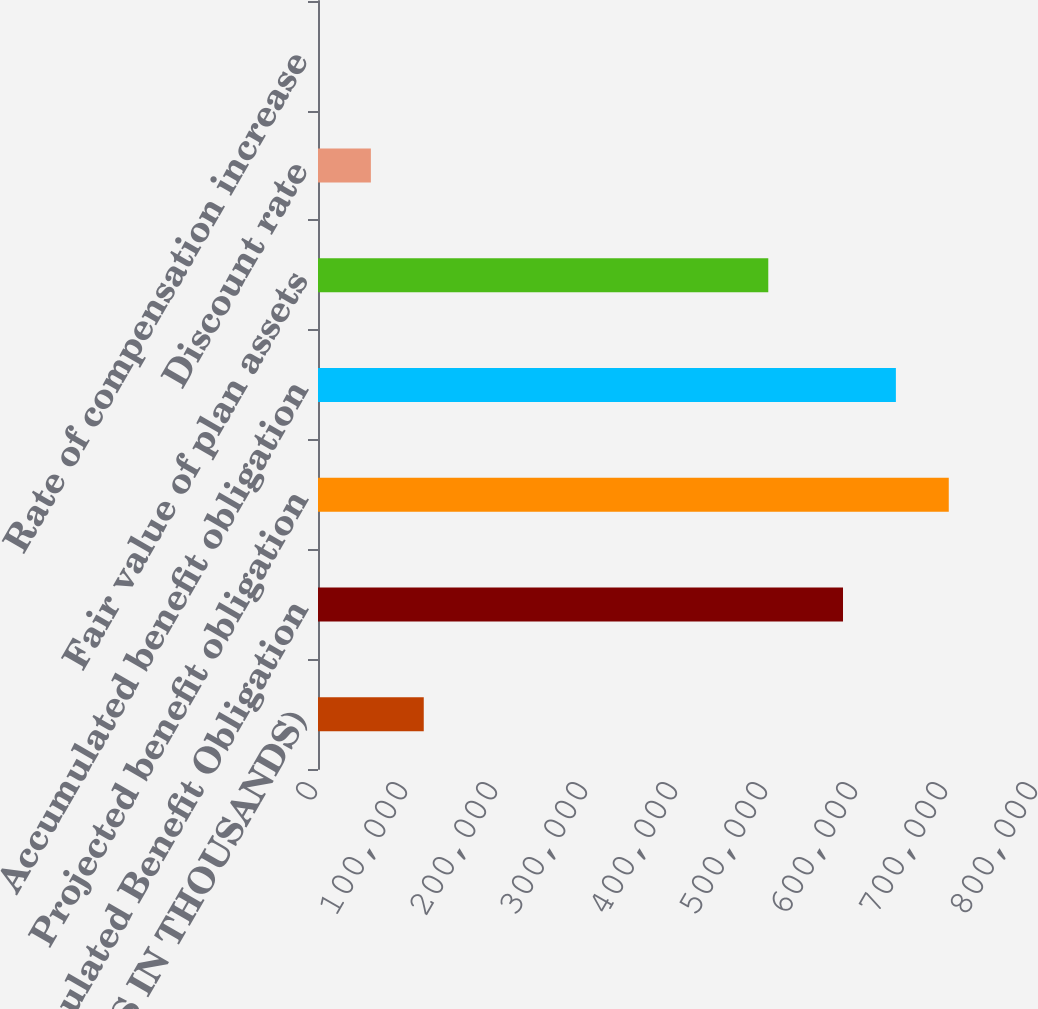Convert chart to OTSL. <chart><loc_0><loc_0><loc_500><loc_500><bar_chart><fcel>(DOLLARS IN THOUSANDS)<fcel>Accumulated Benefit Obligation<fcel>Projected benefit obligation<fcel>Accumulated benefit obligation<fcel>Fair value of plan assets<fcel>Discount rate<fcel>Rate of compensation increase<nl><fcel>117505<fcel>583346<fcel>700848<fcel>642097<fcel>500311<fcel>58754<fcel>3.25<nl></chart> 